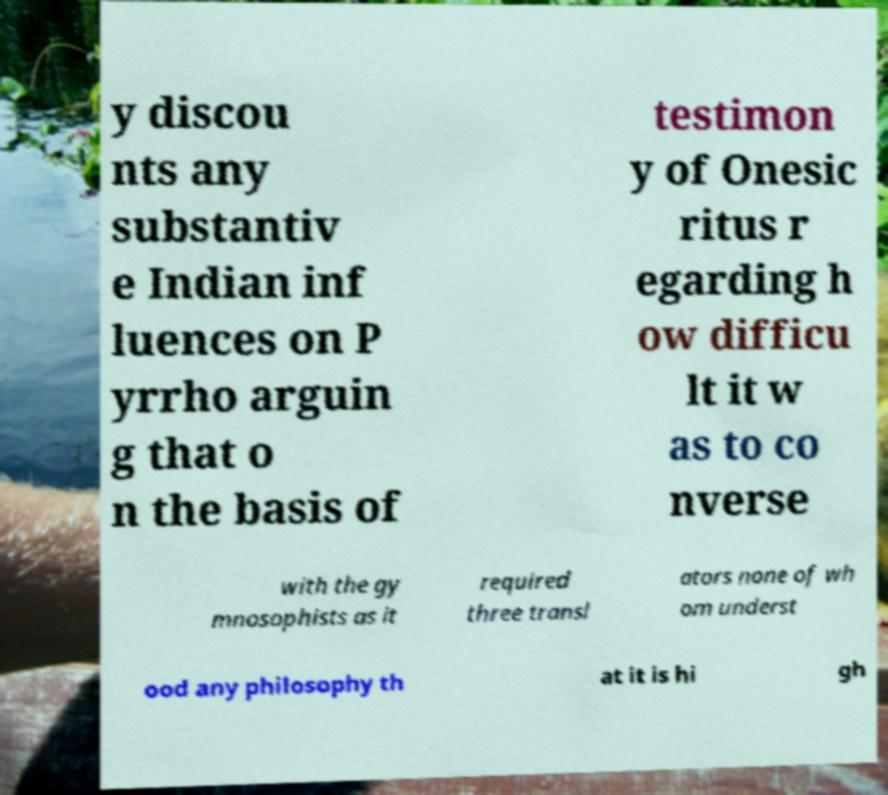There's text embedded in this image that I need extracted. Can you transcribe it verbatim? y discou nts any substantiv e Indian inf luences on P yrrho arguin g that o n the basis of testimon y of Onesic ritus r egarding h ow difficu lt it w as to co nverse with the gy mnosophists as it required three transl ators none of wh om underst ood any philosophy th at it is hi gh 